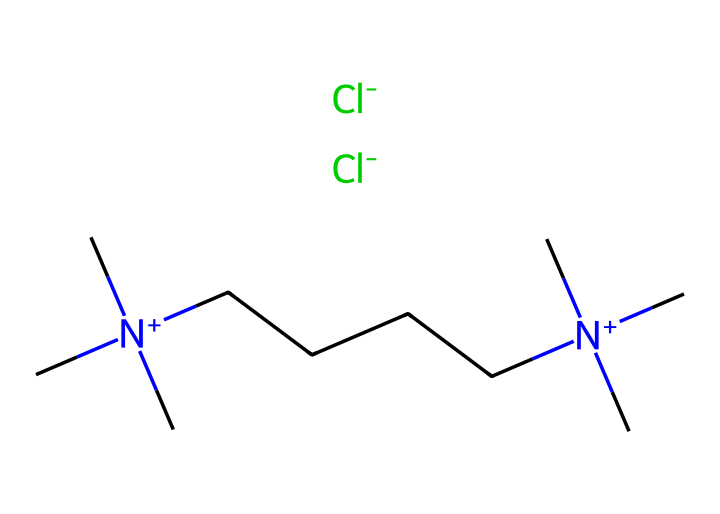What is the main cation present in this ionic liquid? The chemical structure includes two quaternary ammonium groups, which have the nitrogen atoms positively charged. This indicates that the system is dominated by a cationic structure.
Answer: N+ How many carbon atoms are in the longest alkyl chain? By analyzing the structure, the longest continuous carbon chain is identified as having five carbon atoms directly connected. This is determined by counting the carbons from one end of the chain to the other.
Answer: 5 What are the anions associated with this ionic liquid? The chemical has two chloride ions (Cl-) indicated by the presence of "[Cl-]" at the end of the SMILES notation, showing that these are the anionic components of the ionic liquid.
Answer: Cl- What type of interactions are likely dominant in this ionic liquid? Given the presence of quaternary ammonium cations and chloride anions, electrostatic interactions (ionic bonds) are expected to dominate the interactions within this ionic liquid, as these are foundational characteristics of ionic liquids.
Answer: ionic bonds How many nitrogen atoms are present in this chemical structure? Upon evaluating the SMILES representation, there are two nitrogen atoms indicated by the two "[N+]" portions, showcasing that these sites are part of the alkyl ammonium structure.
Answer: 2 What is the significance of the long alkyl chains in this ionic liquid for wound healing? Long alkyl chains help provide hydrophobicity, which is important for improving biocompatibility and solubility in lipid-rich environments found in biological systems, particularly in wound healing applications.
Answer: biocompatibility Which functional groups are characteristic of this ionic liquid? The functional groups are defined by the quaternary ammonium groups (indicated by the nitrogen) and the chloride ions. These groups characterize the structure as an ionic liquid.
Answer: quaternary ammonium and chloride 